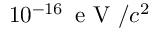Convert formula to latex. <formula><loc_0><loc_0><loc_500><loc_500>1 0 ^ { - 1 6 } \, e V / c ^ { 2 }</formula> 